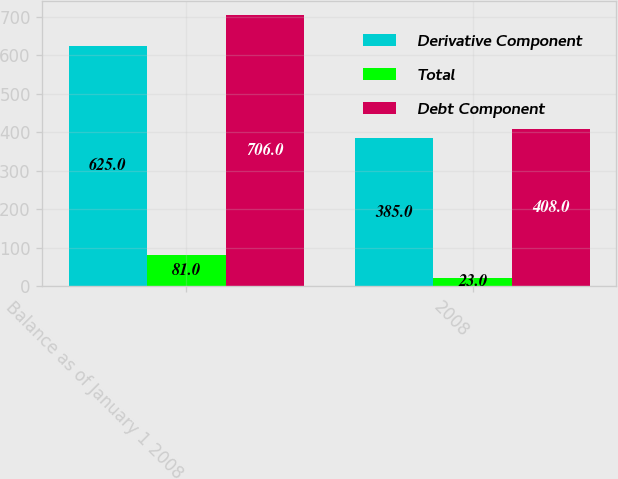Convert chart. <chart><loc_0><loc_0><loc_500><loc_500><stacked_bar_chart><ecel><fcel>Balance as of January 1 2008<fcel>2008<nl><fcel>Derivative Component<fcel>625<fcel>385<nl><fcel>Total<fcel>81<fcel>23<nl><fcel>Debt Component<fcel>706<fcel>408<nl></chart> 